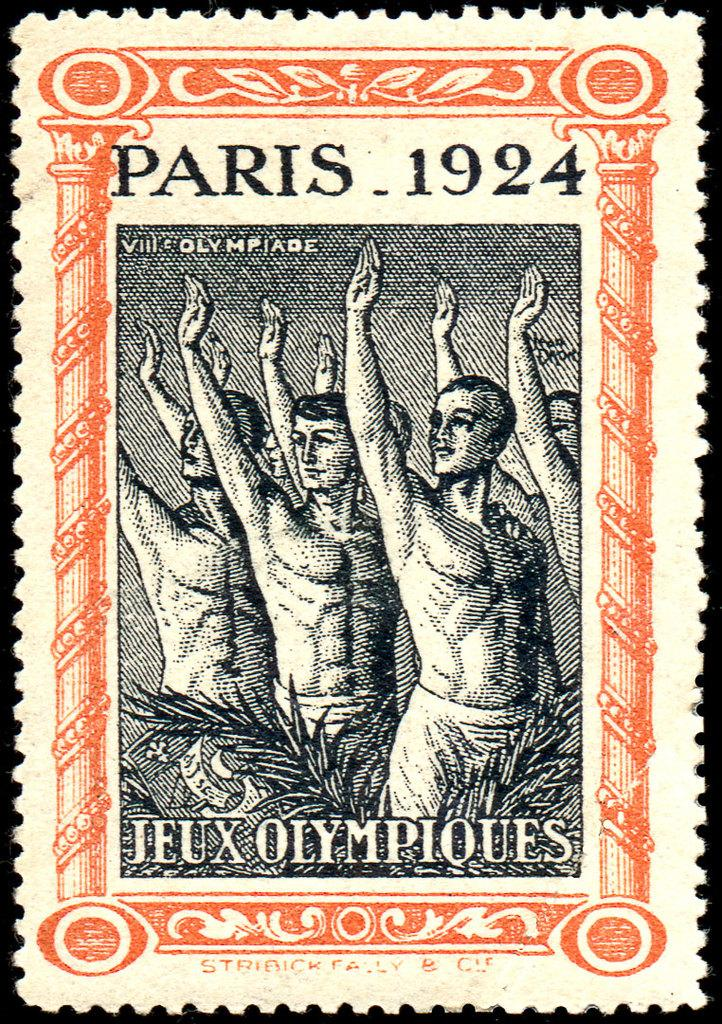What is the main subject of the image? The main subject of the image is a stamp. What is depicted on the stamp? The stamp contains persons and text. What type of magic can be seen happening with the stamp in the image? There is no magic present in the image; it is a static image of a stamp. What type of crate is visible in the image? There is no crate present in the image. 